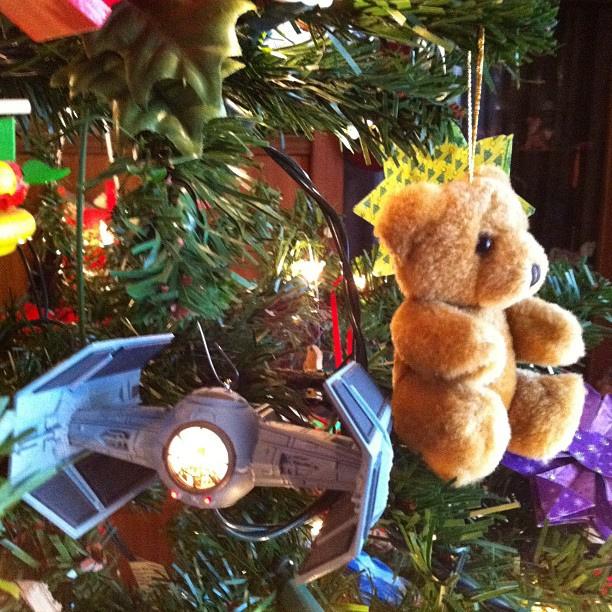What is this hanging bear being used as?
Concise answer only. Ornament. Where is the bear?
Be succinct. On tree. Who flew that ship?
Write a very short answer. Darth vader. How many bears?
Give a very brief answer. 1. 